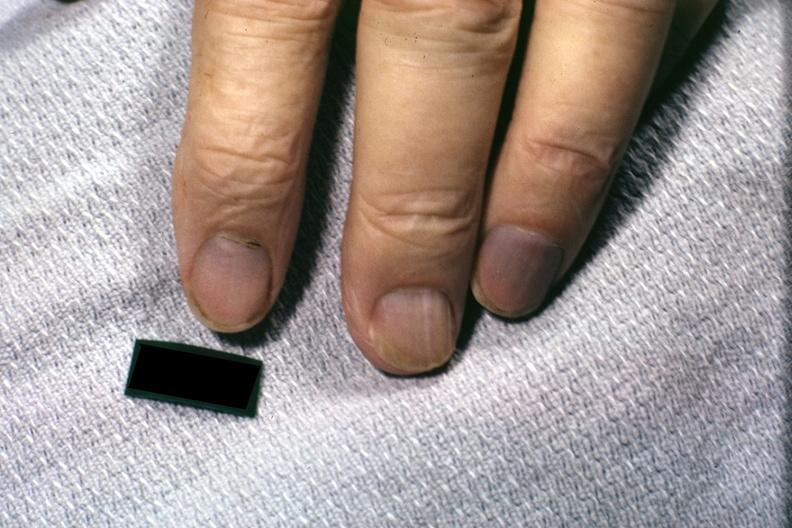s acrocyanosis present?
Answer the question using a single word or phrase. Yes 